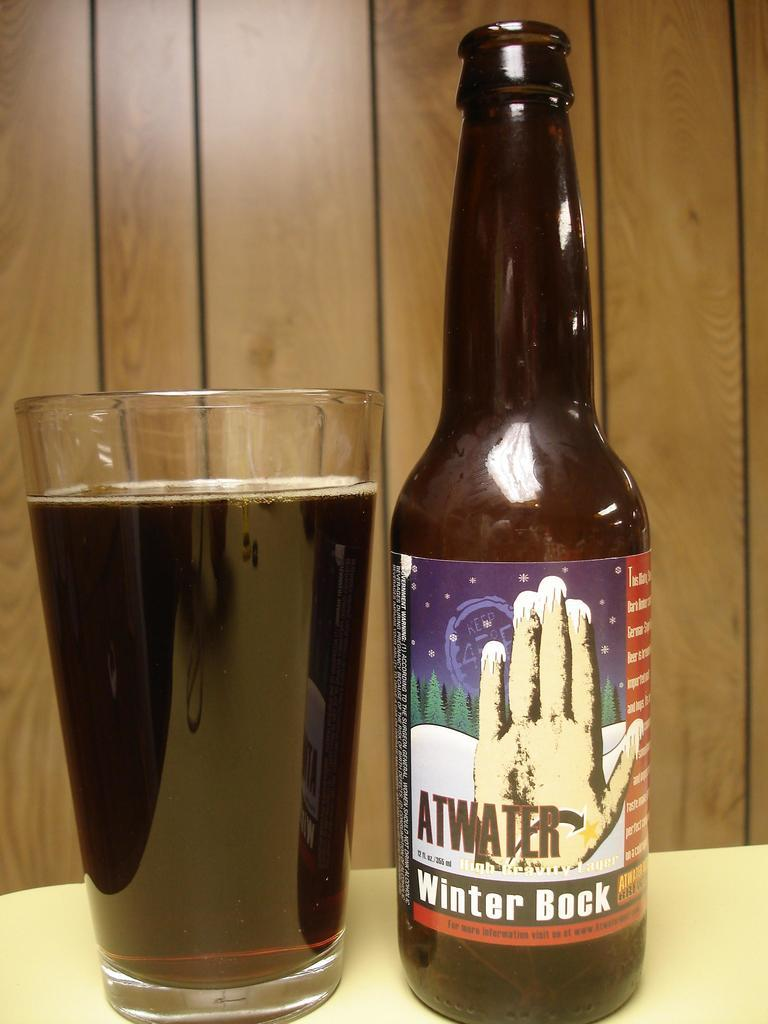What is located in the foreground of the image? There is a glass with a drink in the foreground of the image. What is placed beside the glass on the table? There is a bottle beside the glass on the table. What type of material can be seen in the background of the image? There is a wooden wall in the background of the image. What type of scale can be seen in the image? There is no scale present in the image. How does the cork interact with the drink in the glass? There is no cork present in the image, and therefore no interaction with the drink can be observed. 